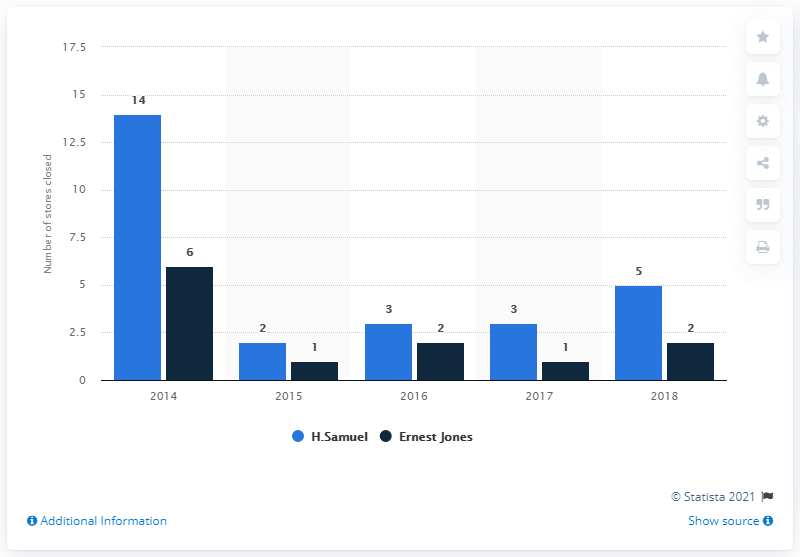Point out several critical features in this image. Signet Jewelers Group owns the jewelry brand H.Samuel in the UK, in addition to owning Ernest Jones. In the fiscal year from 2014 to 2018, a total of 14 stores were closed. 